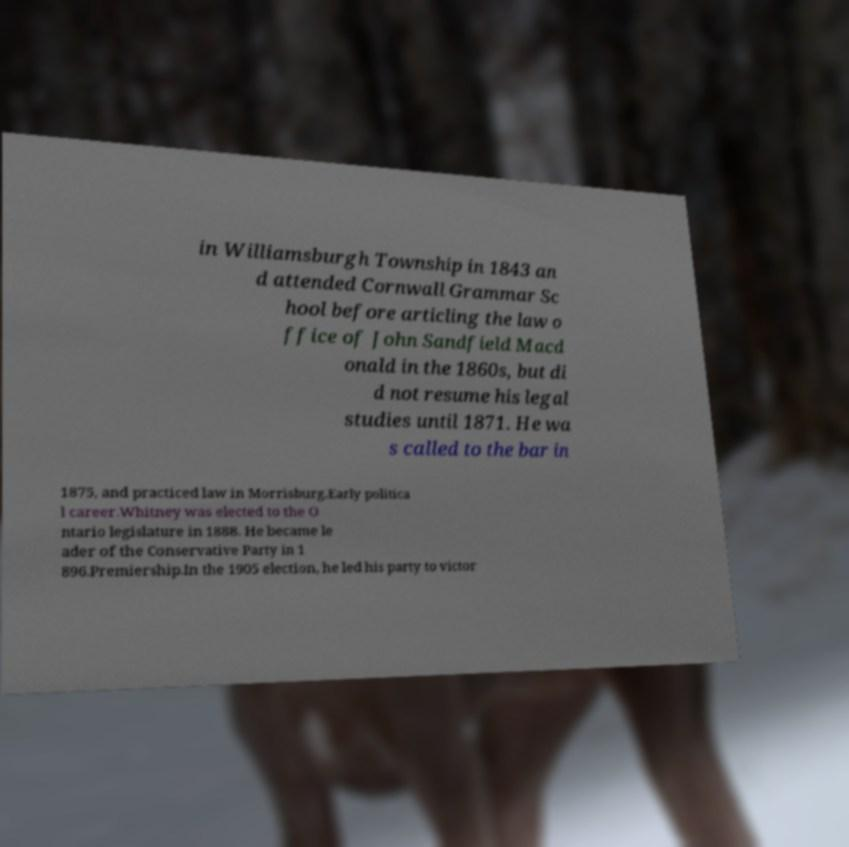Could you assist in decoding the text presented in this image and type it out clearly? in Williamsburgh Township in 1843 an d attended Cornwall Grammar Sc hool before articling the law o ffice of John Sandfield Macd onald in the 1860s, but di d not resume his legal studies until 1871. He wa s called to the bar in 1875, and practiced law in Morrisburg.Early politica l career.Whitney was elected to the O ntario legislature in 1888. He became le ader of the Conservative Party in 1 896.Premiership.In the 1905 election, he led his party to victor 